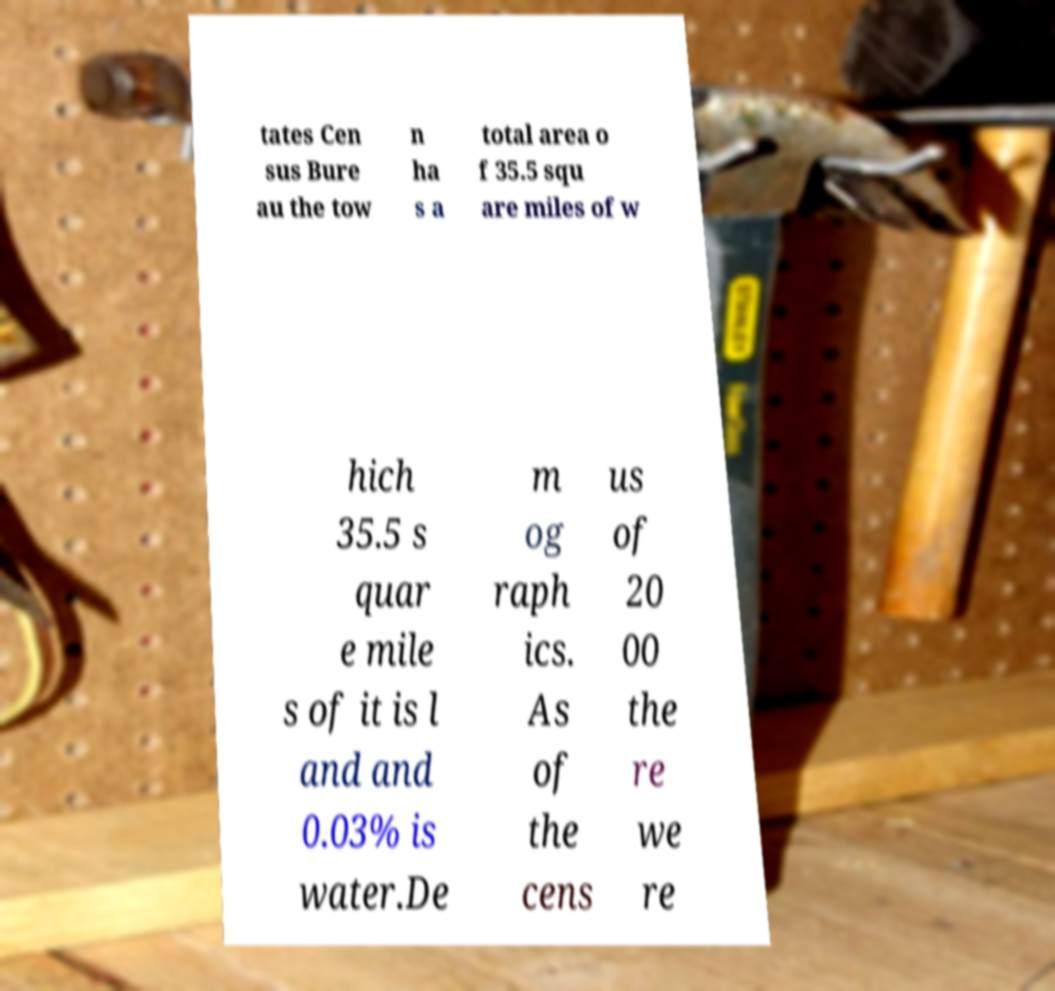There's text embedded in this image that I need extracted. Can you transcribe it verbatim? tates Cen sus Bure au the tow n ha s a total area o f 35.5 squ are miles of w hich 35.5 s quar e mile s of it is l and and 0.03% is water.De m og raph ics. As of the cens us of 20 00 the re we re 